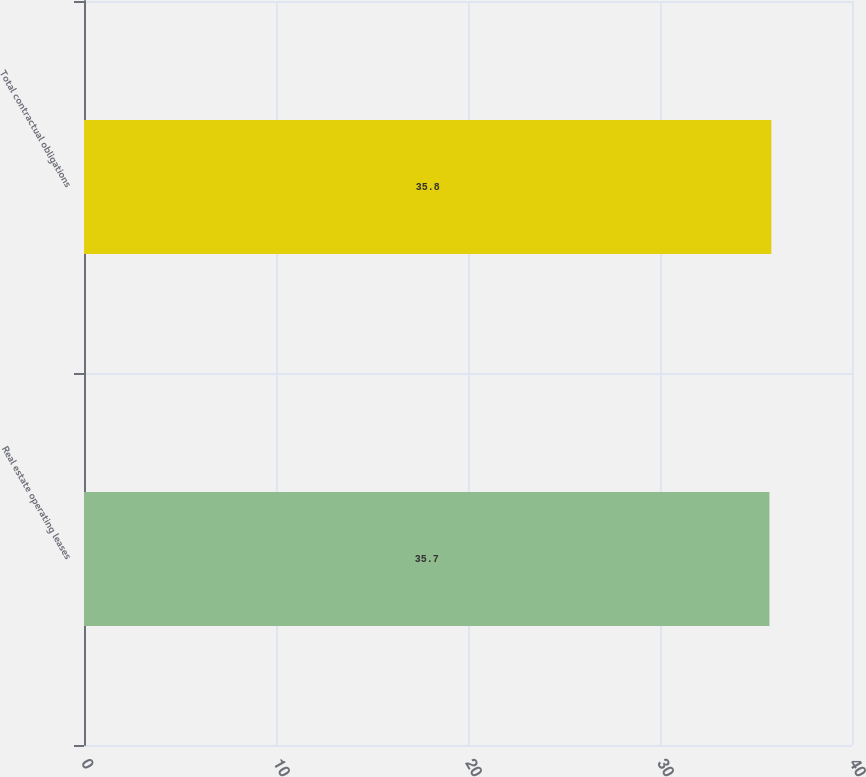Convert chart to OTSL. <chart><loc_0><loc_0><loc_500><loc_500><bar_chart><fcel>Real estate operating leases<fcel>Total contractual obligations<nl><fcel>35.7<fcel>35.8<nl></chart> 